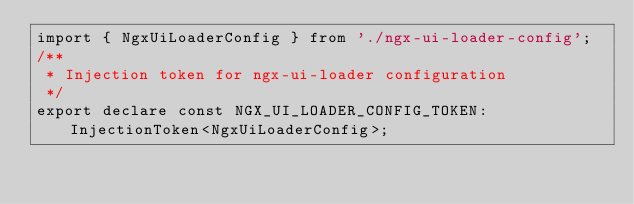<code> <loc_0><loc_0><loc_500><loc_500><_TypeScript_>import { NgxUiLoaderConfig } from './ngx-ui-loader-config';
/**
 * Injection token for ngx-ui-loader configuration
 */
export declare const NGX_UI_LOADER_CONFIG_TOKEN: InjectionToken<NgxUiLoaderConfig>;
</code> 